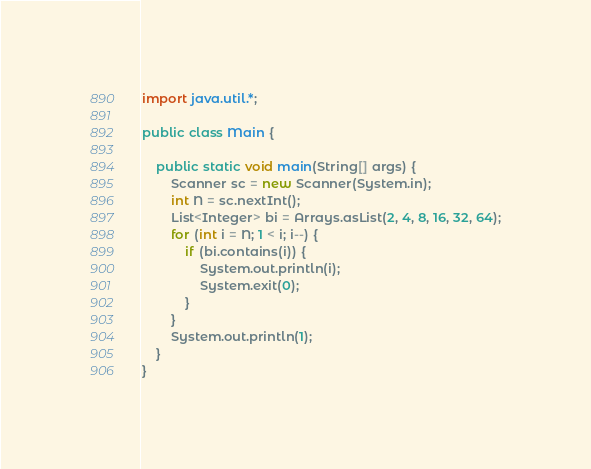Convert code to text. <code><loc_0><loc_0><loc_500><loc_500><_Java_>import java.util.*;
 
public class Main {
	
    public static void main(String[] args) {
    	Scanner sc = new Scanner(System.in);
    	int N = sc.nextInt();
    	List<Integer> bi = Arrays.asList(2, 4, 8, 16, 32, 64);
    	for (int i = N; 1 < i; i--) {
    		if (bi.contains(i)) {
    			System.out.println(i);
    			System.exit(0);
    		}
    	}
    	System.out.println(1);
    }
}</code> 